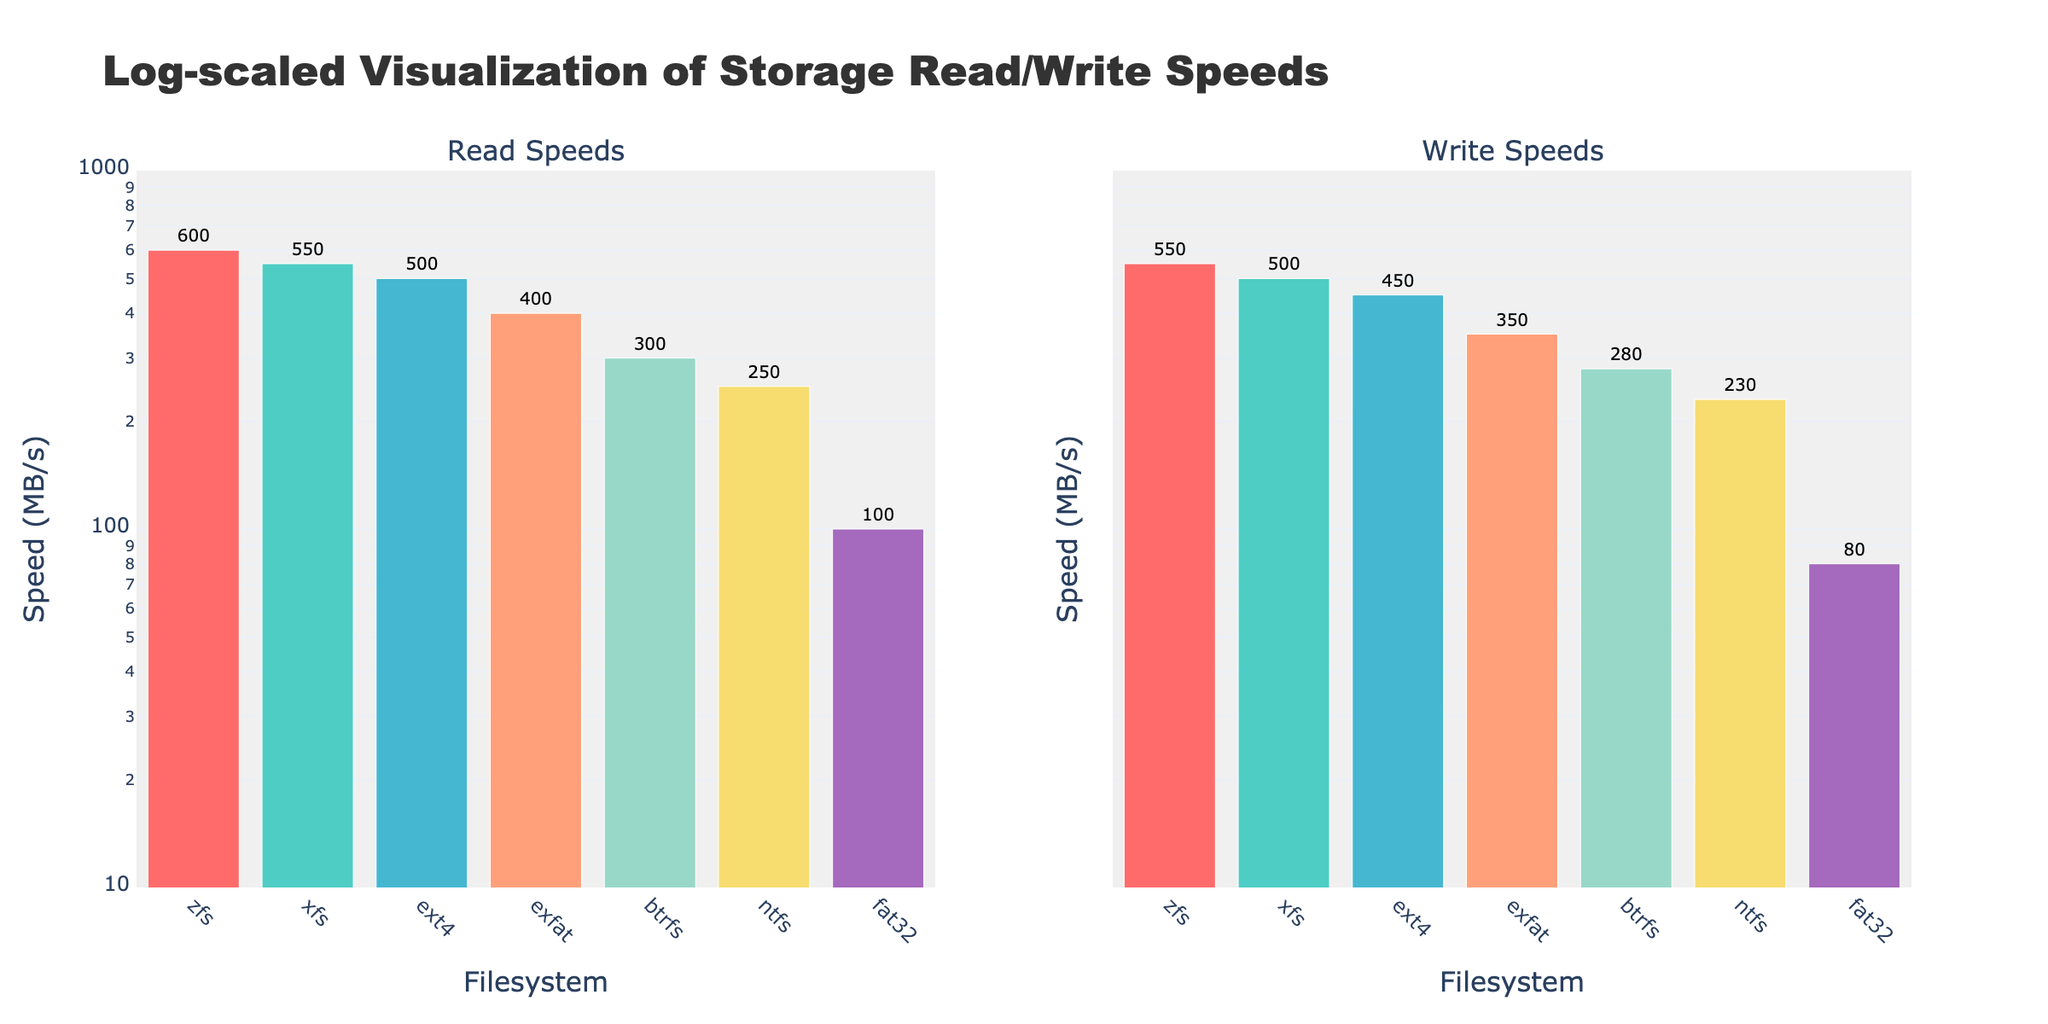What's the title of the plot? The title of the plot is displayed at the top of the figure, which states the main subject of the visualization.
Answer: Log-scaled Visualization of Storage Read/Write Speeds How many filesystems are compared in the plot? By counting the different filesystem labels along the x-axis in either subplot, we can determine the number of filesystems.
Answer: 7 Which filesystem has the highest read speed? By looking at the bar heights in the first subplot (Read Speeds) and noting the y-axis labels, we can identify the tallest bar corresponding to the highest read speed.
Answer: zfs Which filesystem has the lowest write speed? By looking at the bar heights in the second subplot (Write Speeds) and noting the y-axis labels, we can identify the shortest bar corresponding to the lowest write speed.
Answer: fat32 What is the difference between the read speed and write speed of the filesystem 'xfs'? Find the bar representing 'xfs' in both subplots and subtract the write speed value from the read speed value.
Answer: 50 Which filesystem shows greater performance in read speeds, 'ext4' or 'ntfs'? Compare the heights of the bars corresponding to 'ext4' and 'ntfs' in the first subplot.
Answer: ext4 Which operation, read or write, shows a greater speed variance among the filesystems? Compare the spread of the bar heights in both subplots, noting how far the values vary in each case.
Answer: Read Looking at the read speeds, what is the approximate ratio between the highest speed and the lowest speed? Identify the highest and lowest read speeds in the first subplot and calculate the ratio of the highest speed to the lowest speed.
Answer: 6:1 (600 MBps / 100 MBps) What is the average write speed for the filesystems? Add the write speed values for all the filesystems and divide the sum by the number of filesystems.
Answer: 348.57 MBps In log scale plots, does the equal spacing between ticks represent equal differences or equal ratios in values? Analyze the y-axis ticks and their labels to understand the representation in log scale, where spacing indicates ratios rather than differences.
Answer: Equal ratios 